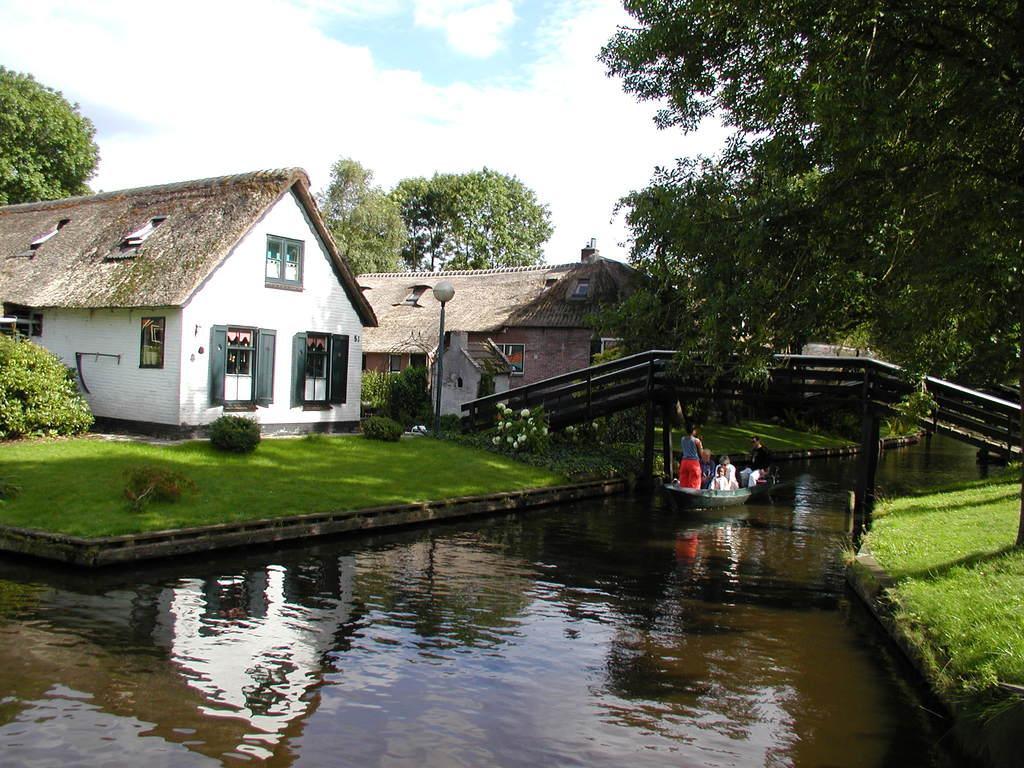Could you give a brief overview of what you see in this image? In this picture I can see the water in the center and I can see a boat on which there are people and I can see a bridge and I can see the grass and trees on both the sides of this picture. I can also see few plants. In the background I can see the buildings, a light pole and the sky. 